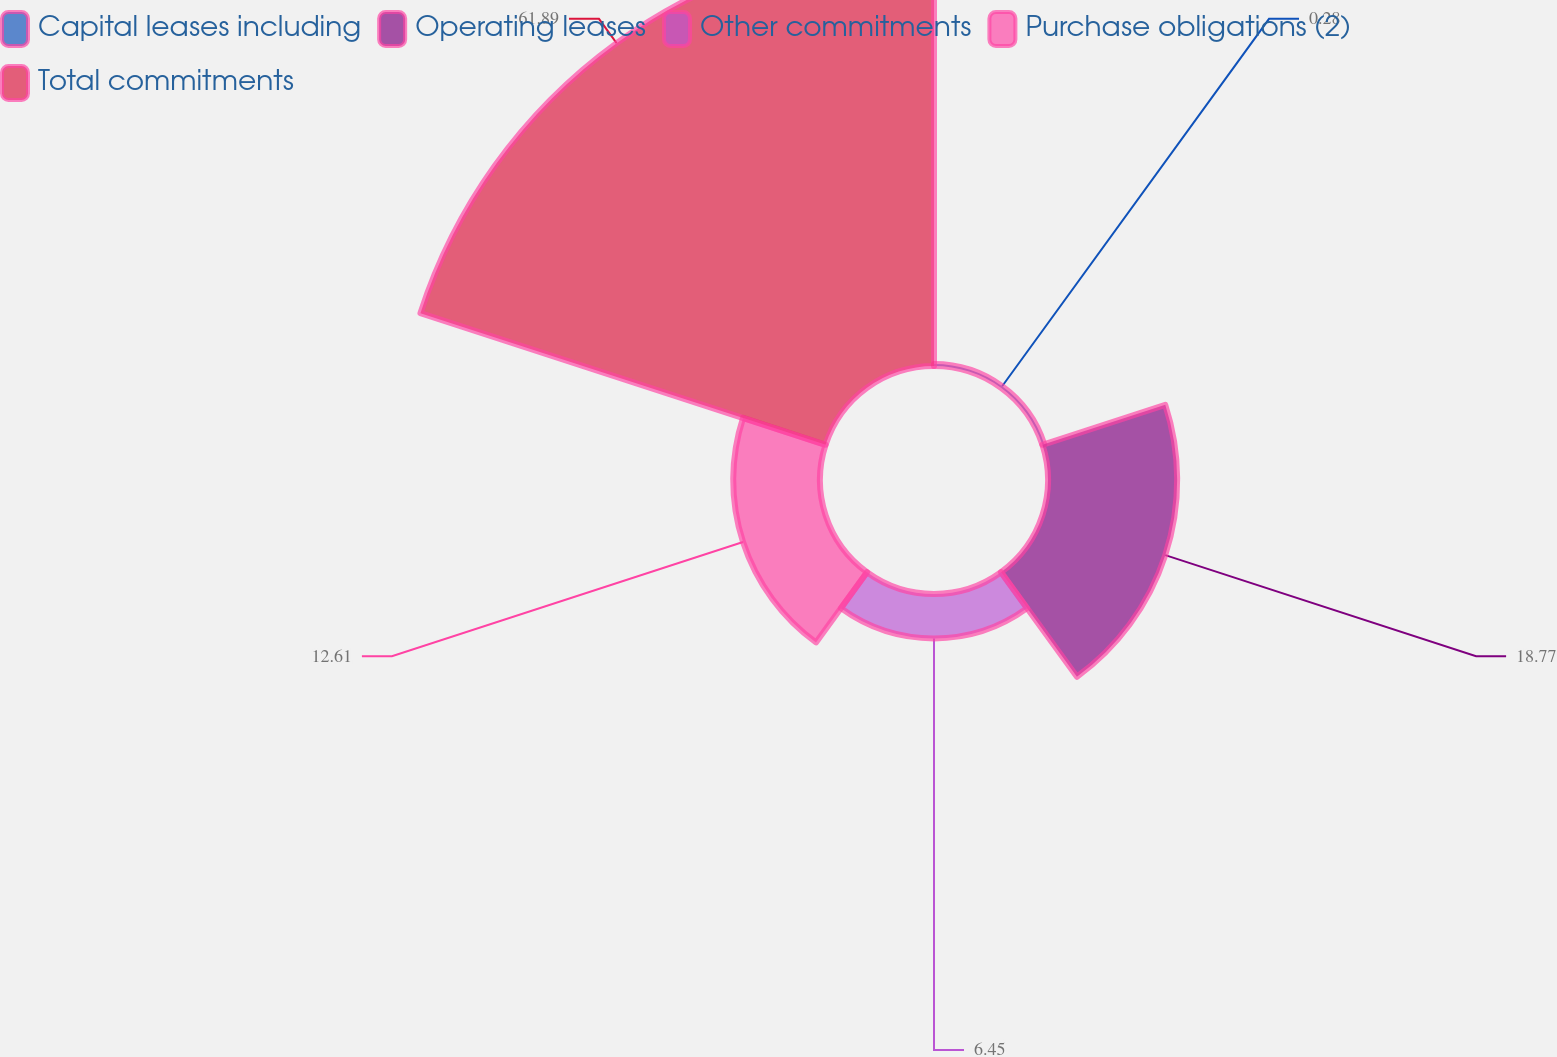Convert chart to OTSL. <chart><loc_0><loc_0><loc_500><loc_500><pie_chart><fcel>Capital leases including<fcel>Operating leases<fcel>Other commitments<fcel>Purchase obligations (2)<fcel>Total commitments<nl><fcel>0.28%<fcel>18.77%<fcel>6.45%<fcel>12.61%<fcel>61.9%<nl></chart> 